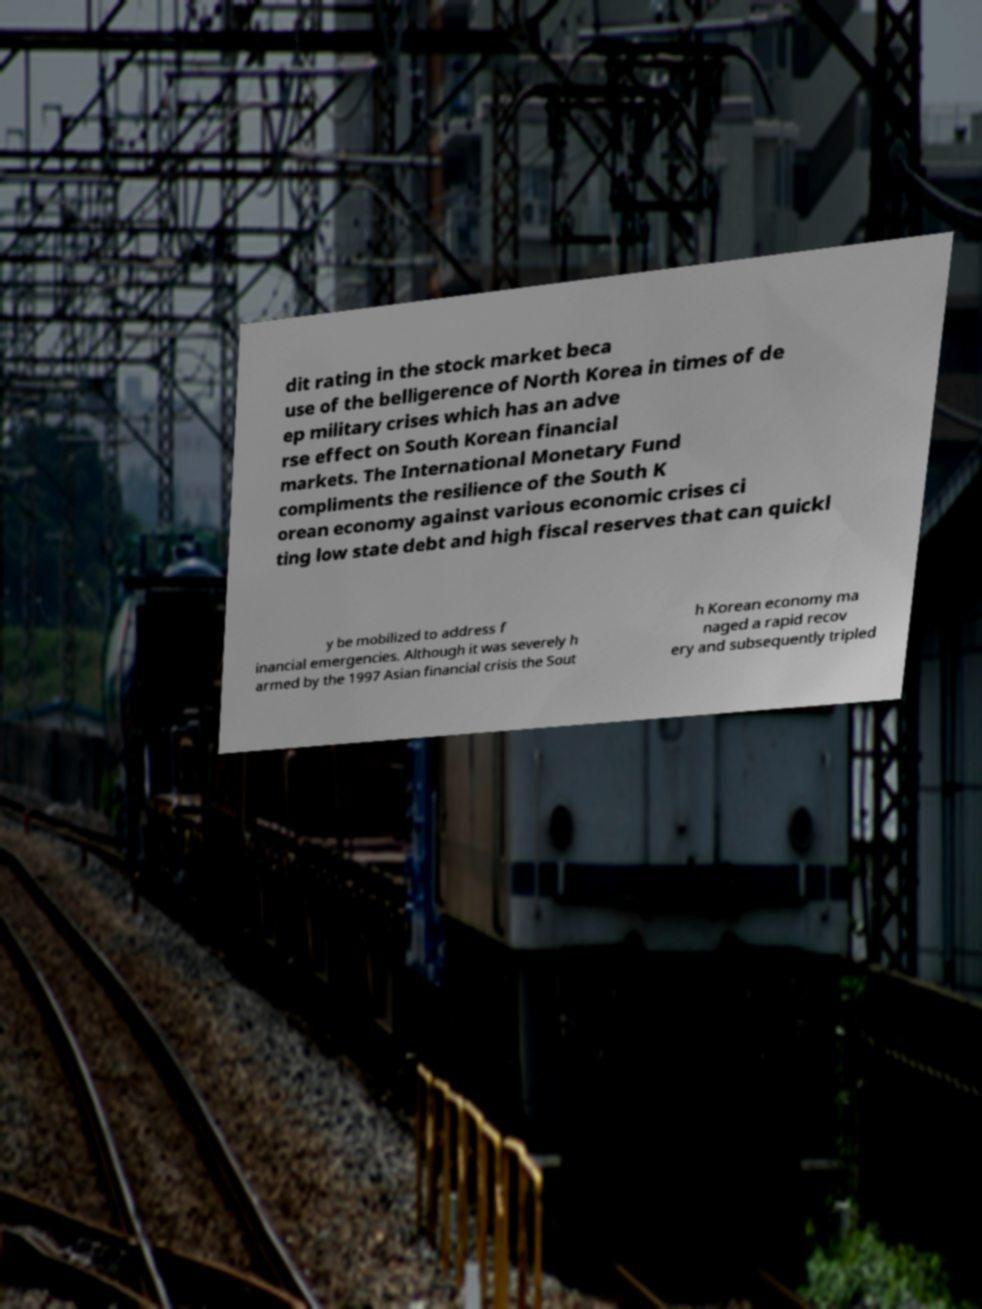Can you read and provide the text displayed in the image?This photo seems to have some interesting text. Can you extract and type it out for me? dit rating in the stock market beca use of the belligerence of North Korea in times of de ep military crises which has an adve rse effect on South Korean financial markets. The International Monetary Fund compliments the resilience of the South K orean economy against various economic crises ci ting low state debt and high fiscal reserves that can quickl y be mobilized to address f inancial emergencies. Although it was severely h armed by the 1997 Asian financial crisis the Sout h Korean economy ma naged a rapid recov ery and subsequently tripled 